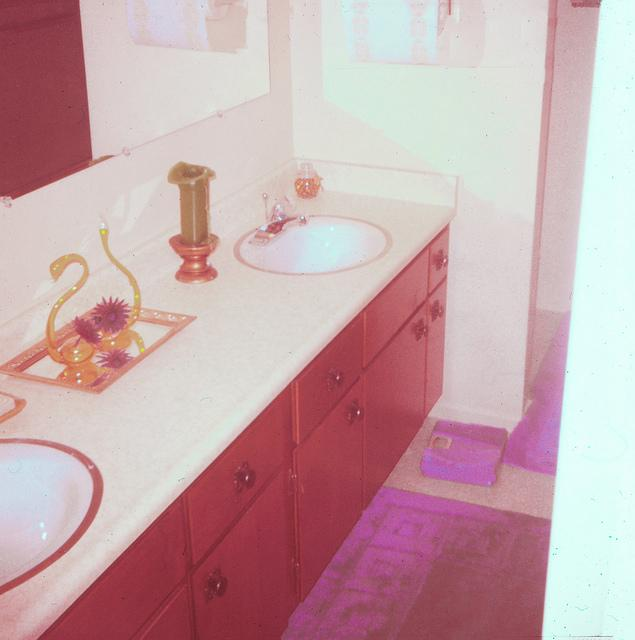What item on the counter has melted?

Choices:
A) flower
B) candle
C) tray
D) soap candle 